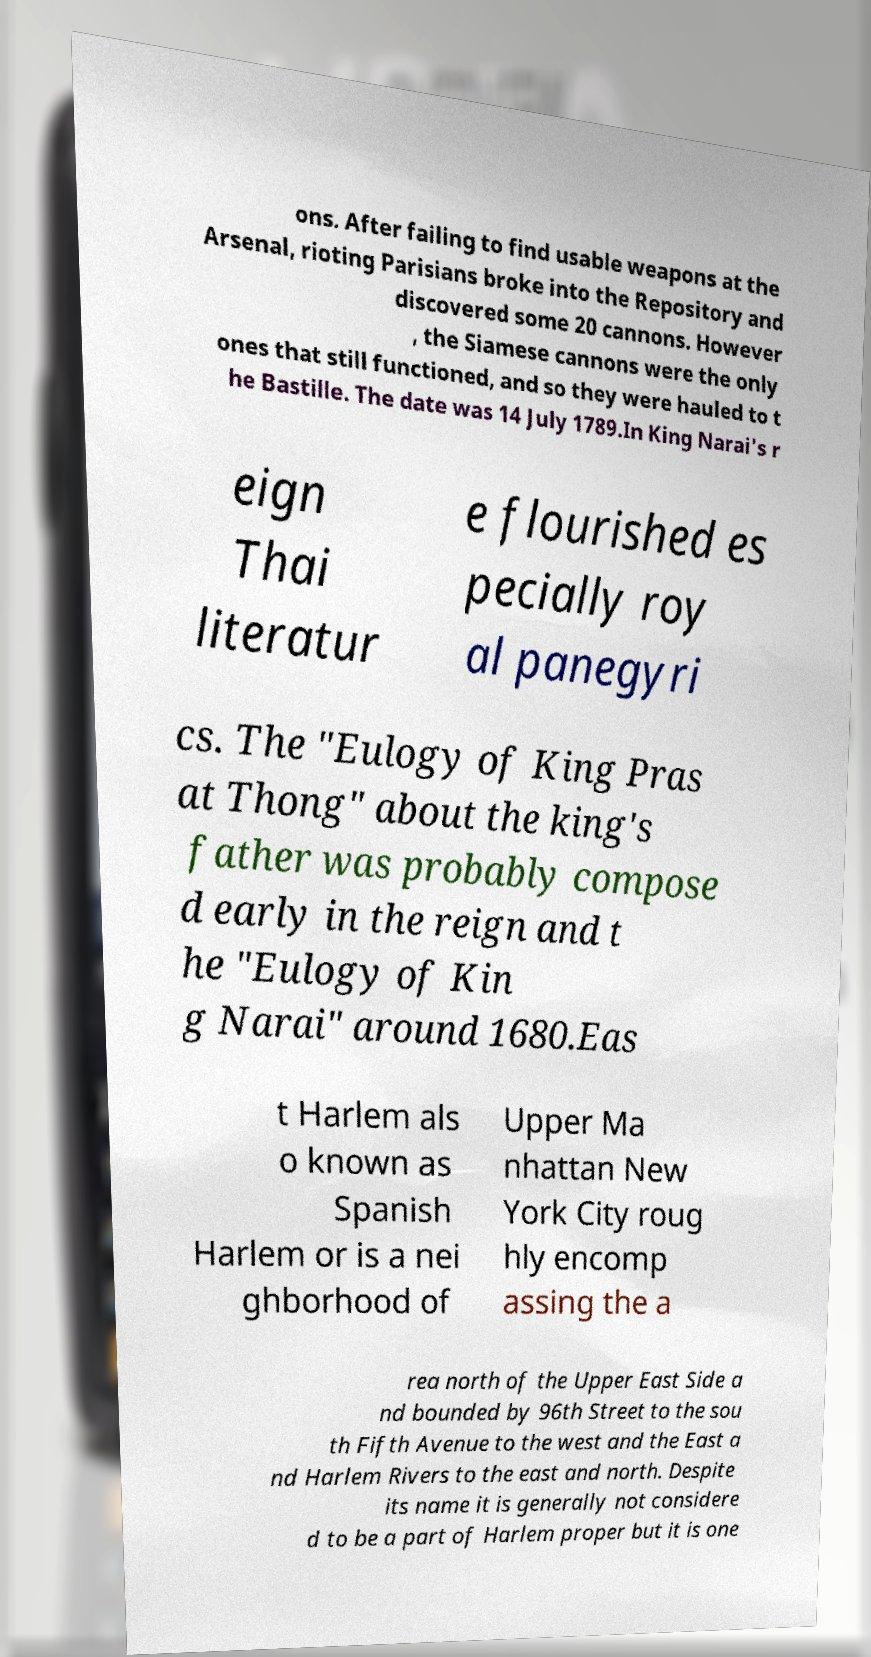Can you read and provide the text displayed in the image?This photo seems to have some interesting text. Can you extract and type it out for me? ons. After failing to find usable weapons at the Arsenal, rioting Parisians broke into the Repository and discovered some 20 cannons. However , the Siamese cannons were the only ones that still functioned, and so they were hauled to t he Bastille. The date was 14 July 1789.In King Narai's r eign Thai literatur e flourished es pecially roy al panegyri cs. The "Eulogy of King Pras at Thong" about the king's father was probably compose d early in the reign and t he "Eulogy of Kin g Narai" around 1680.Eas t Harlem als o known as Spanish Harlem or is a nei ghborhood of Upper Ma nhattan New York City roug hly encomp assing the a rea north of the Upper East Side a nd bounded by 96th Street to the sou th Fifth Avenue to the west and the East a nd Harlem Rivers to the east and north. Despite its name it is generally not considere d to be a part of Harlem proper but it is one 